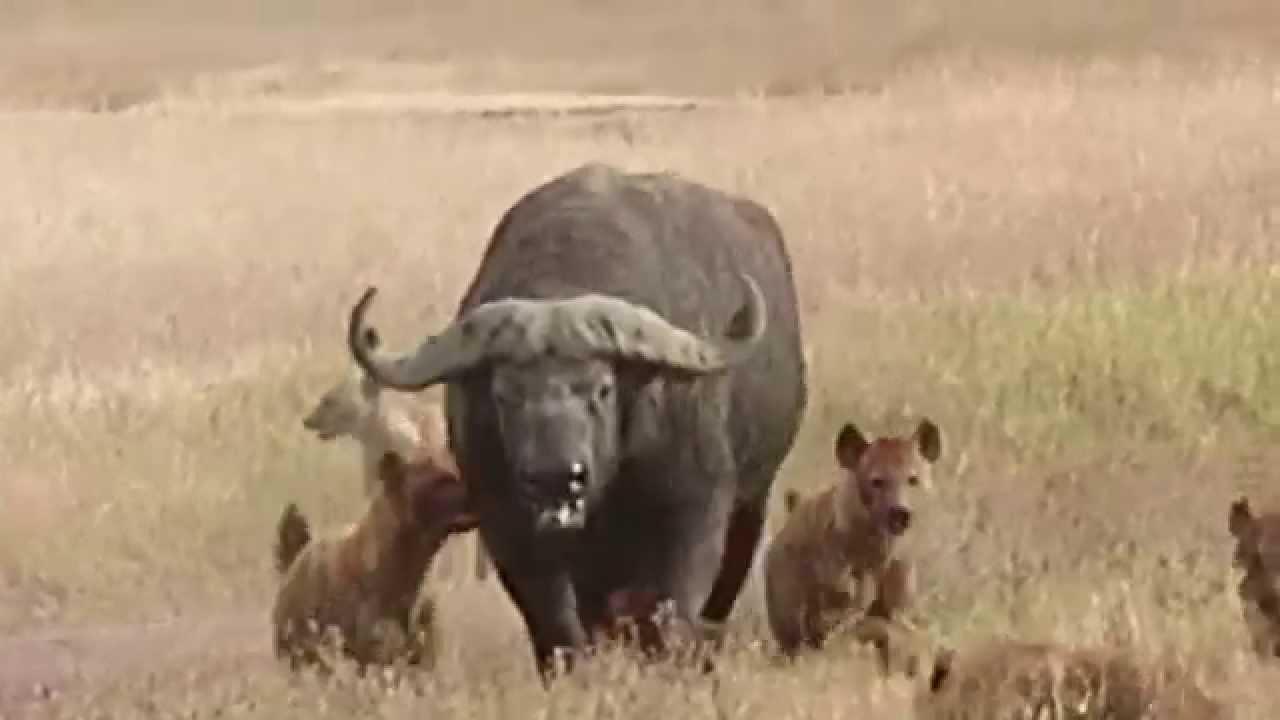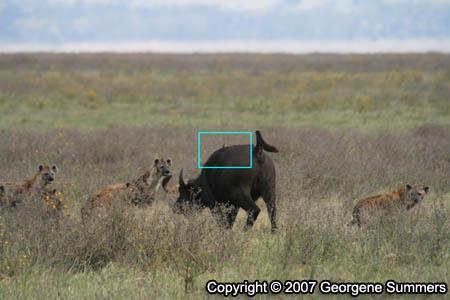The first image is the image on the left, the second image is the image on the right. Examine the images to the left and right. Is the description "an animal is being eaten on the left pic" accurate? Answer yes or no. No. The first image is the image on the left, the second image is the image on the right. For the images shown, is this caption "Hyenas are circling their prey, which is still up on all 4 legs in both images." true? Answer yes or no. Yes. 